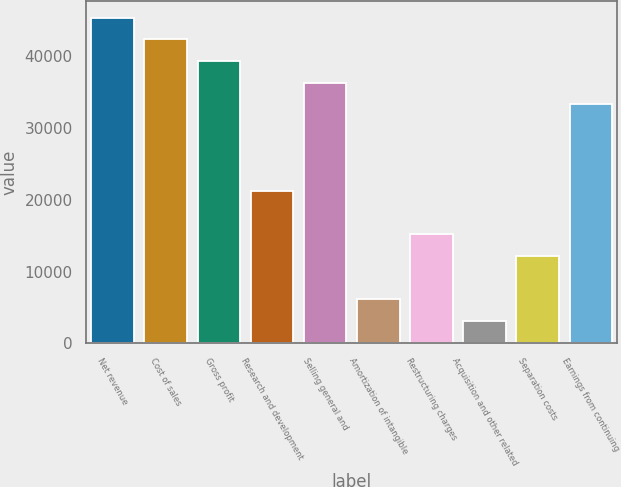Convert chart to OTSL. <chart><loc_0><loc_0><loc_500><loc_500><bar_chart><fcel>Net revenue<fcel>Cost of sales<fcel>Gross profit<fcel>Research and development<fcel>Selling general and<fcel>Amortization of intangible<fcel>Restructuring charges<fcel>Acquisition and other related<fcel>Separation costs<fcel>Earnings from continuing<nl><fcel>45382<fcel>42361.6<fcel>39341.2<fcel>21218.8<fcel>36320.8<fcel>6116.8<fcel>15178<fcel>3096.4<fcel>12157.6<fcel>33300.4<nl></chart> 